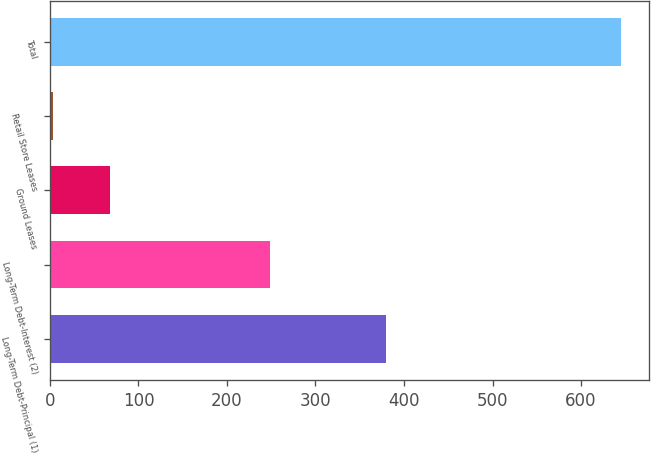<chart> <loc_0><loc_0><loc_500><loc_500><bar_chart><fcel>Long-Term Debt-Principal (1)<fcel>Long-Term Debt-Interest (2)<fcel>Ground Leases<fcel>Retail Store Leases<fcel>Total<nl><fcel>380<fcel>248.1<fcel>67.82<fcel>3.7<fcel>644.9<nl></chart> 